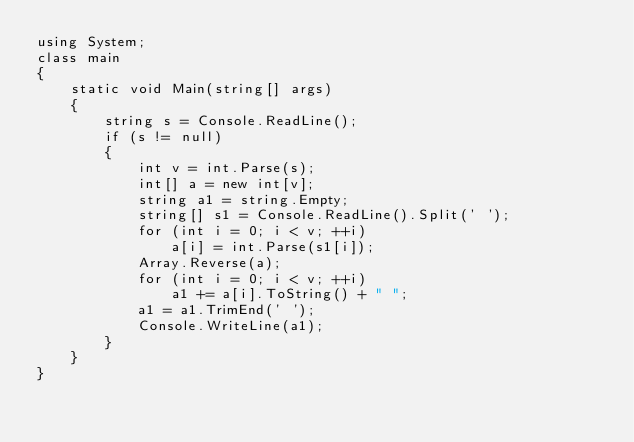Convert code to text. <code><loc_0><loc_0><loc_500><loc_500><_C#_>using System;
class main
{
    static void Main(string[] args)
    {
        string s = Console.ReadLine();
        if (s != null)
        {
            int v = int.Parse(s);
            int[] a = new int[v];
            string a1 = string.Empty;
            string[] s1 = Console.ReadLine().Split(' ');
            for (int i = 0; i < v; ++i)
                a[i] = int.Parse(s1[i]);
            Array.Reverse(a);
            for (int i = 0; i < v; ++i)
                a1 += a[i].ToString() + " ";
            a1 = a1.TrimEnd(' ');
            Console.WriteLine(a1);
        }
    }
}</code> 